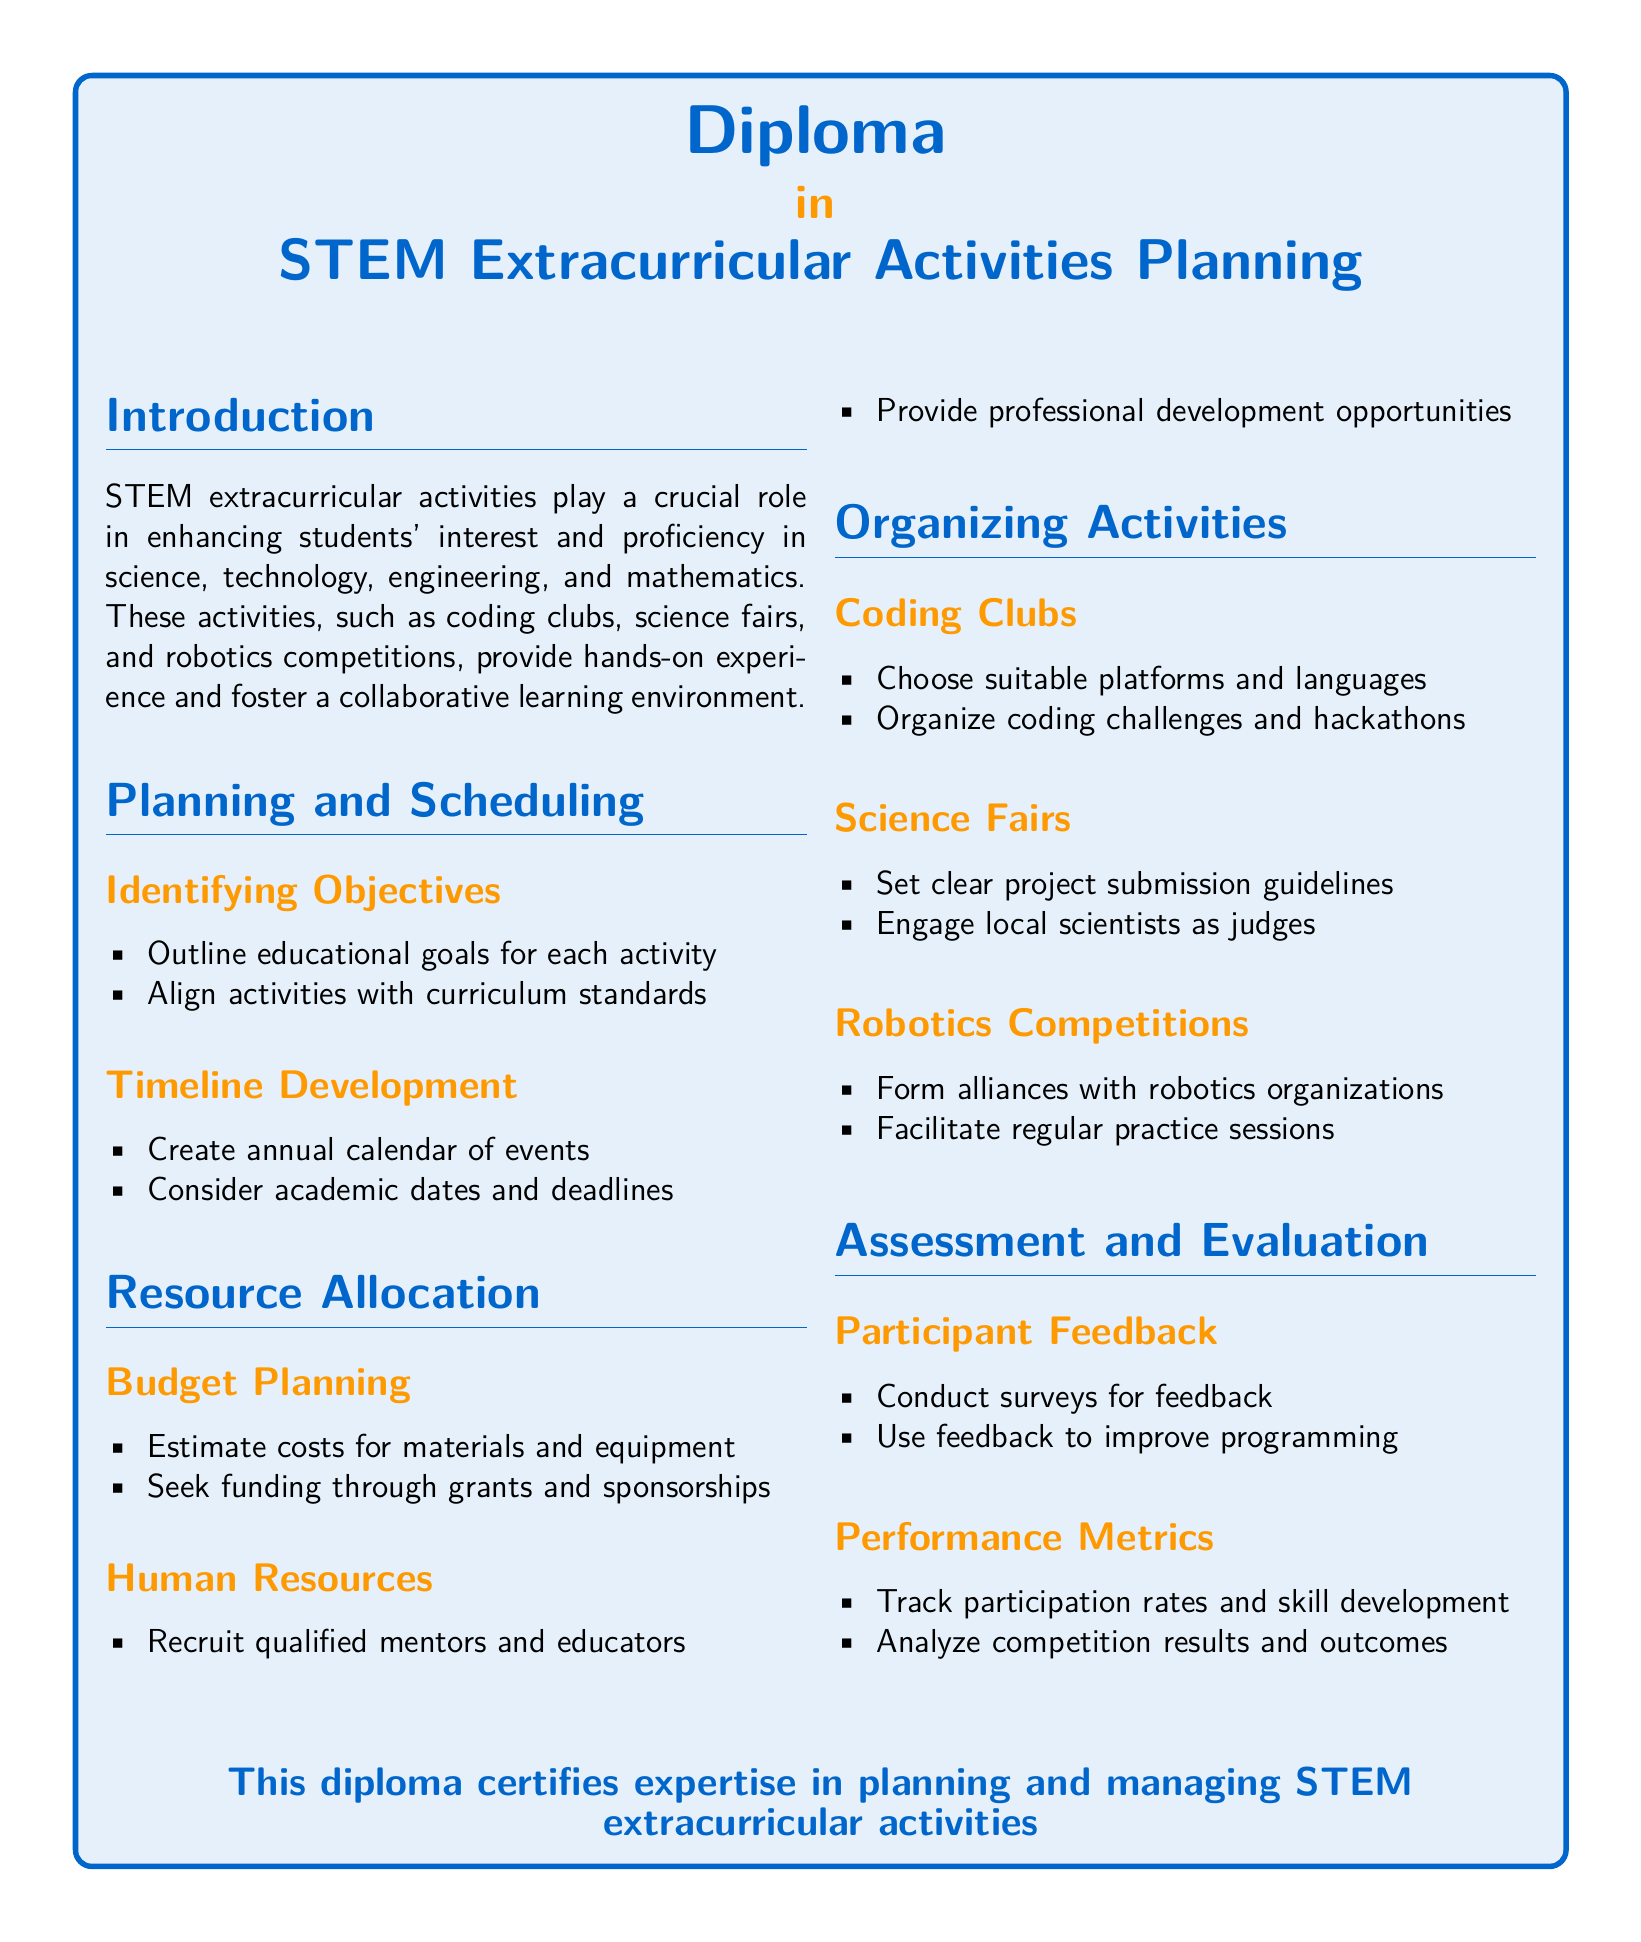What is the title of the diploma? The title of the diploma is prominently displayed at the top of the document, indicating its focus on STEM extracurricular activities planning.
Answer: STEM Extracurricular Activities Planning What are two types of STEM-related activities mentioned? The document outlines various types of STEM-related extracurricular activities, explicitly mentioning coding clubs and science fairs as examples.
Answer: coding clubs, science fairs What section addresses budget planning? The section specifically dedicated to financial considerations is clearly identified within the document’s structure, indicating where budget-related planning occurs.
Answer: Resource Allocation How many items are listed under "Human Resources"? The document includes a specific number of items under each relevant subsection, allowing for easy retrieval of how many aspects are discussed in the relevant category.
Answer: 2 What do regular practice sessions facilitate? The document identifies specific activities associated with the organization of robotics competitions, highlighting the importance of certain preparatory actions.
Answer: regular practice sessions What is one method for participant feedback? The document suggests a straightforward approach for gathering participant insights, making it easy to pinpoint the methods proposed for ensuring feedback is obtained.
Answer: Conduct surveys What is a goal of engaging local scientists in science fairs? The document mentions a specific role for external participants in the organization, clarifying the intention behind their inclusion in the activity's structure.
Answer: as judges What type of professionals should be recruited according to the document? The text specifies a category of individuals whose expertise is crucial for effective planning in STEM extracurricular activities.
Answer: qualified mentors 